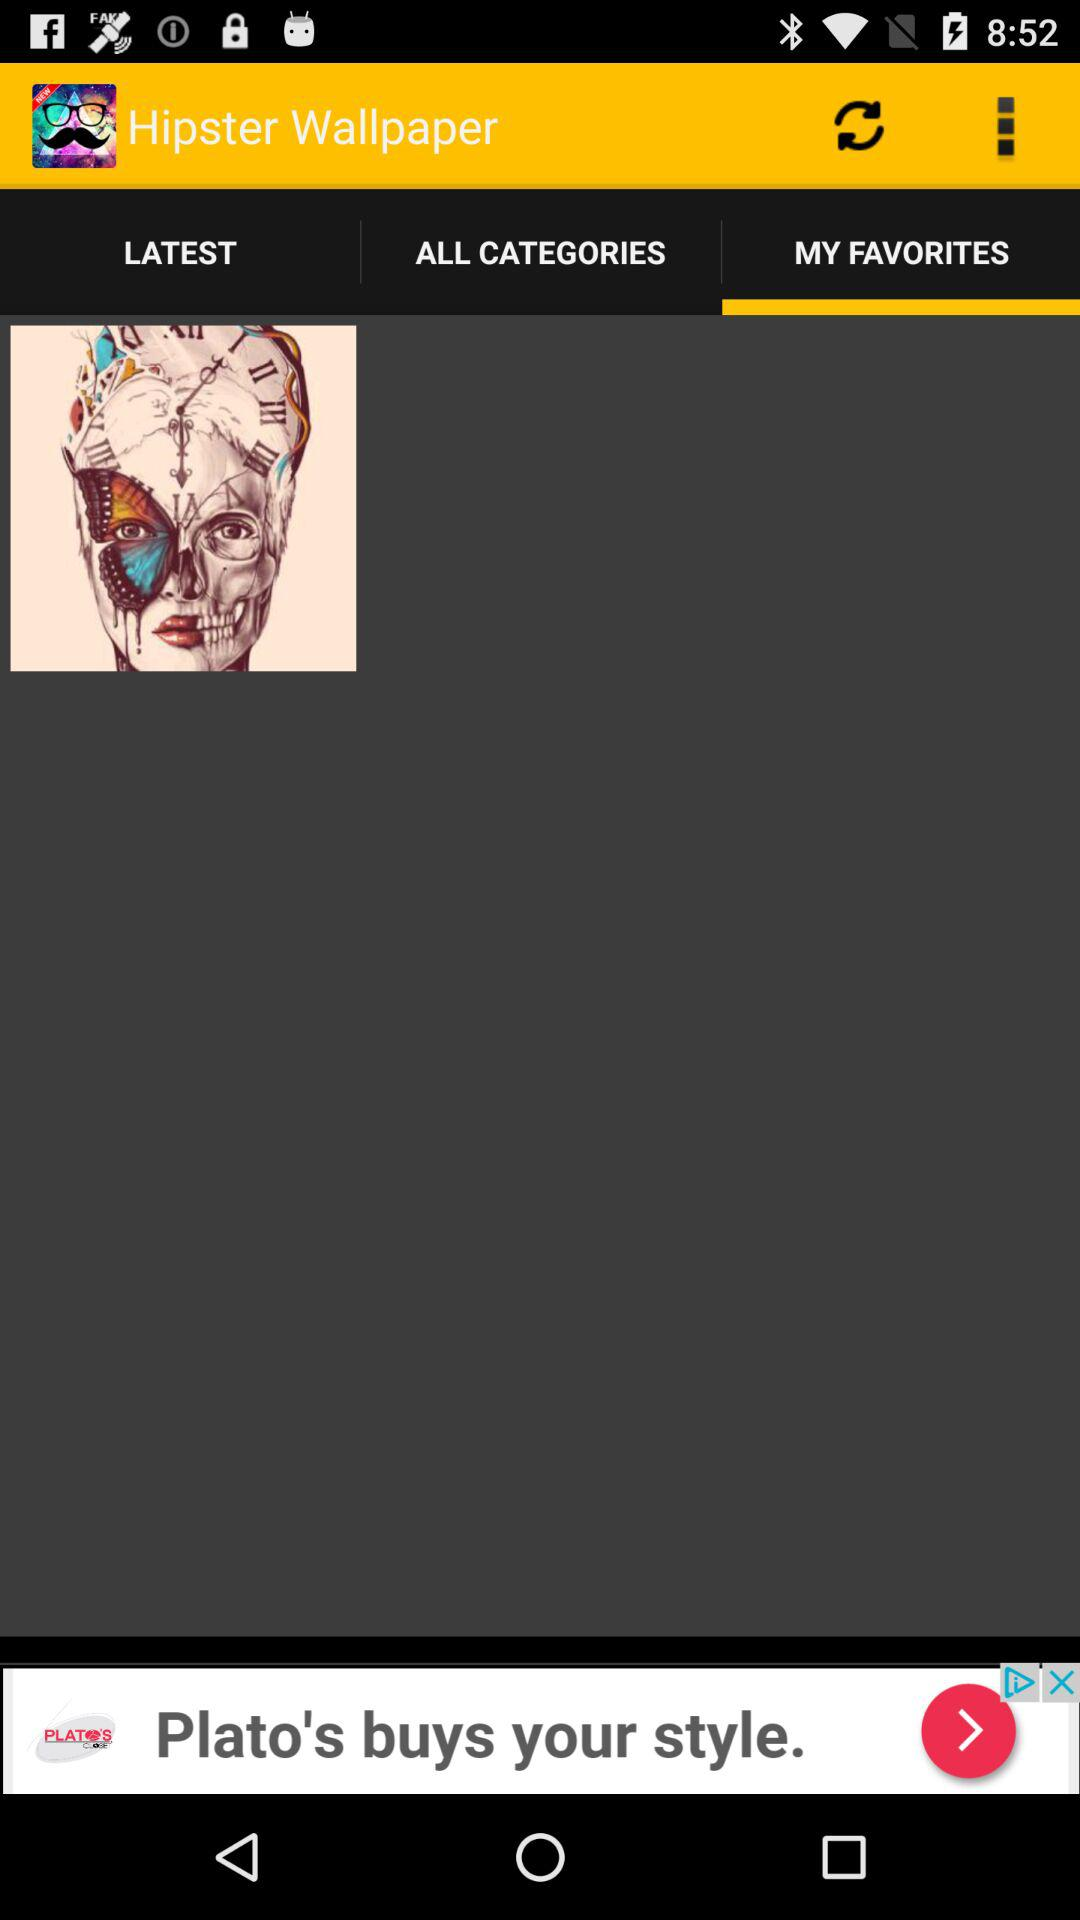What tab is selected? The selected tab is "MY FAVORITES". 